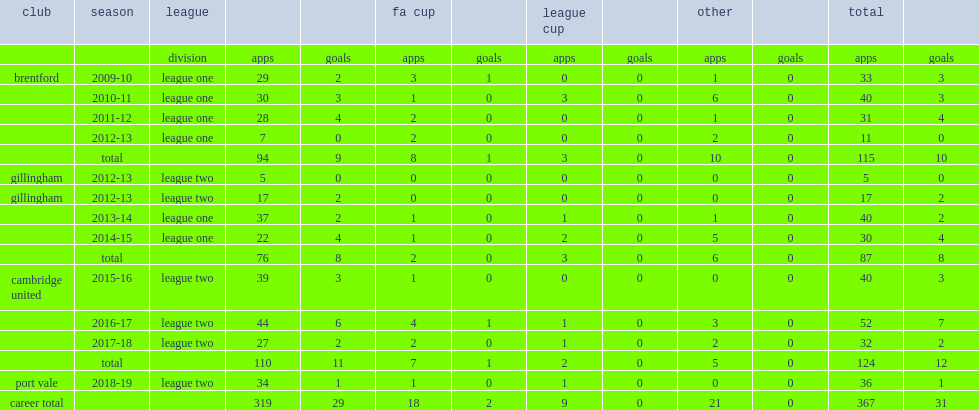How many appearances did leon legge make for gillingham with league one during the 2013-14 season? 40.0. 